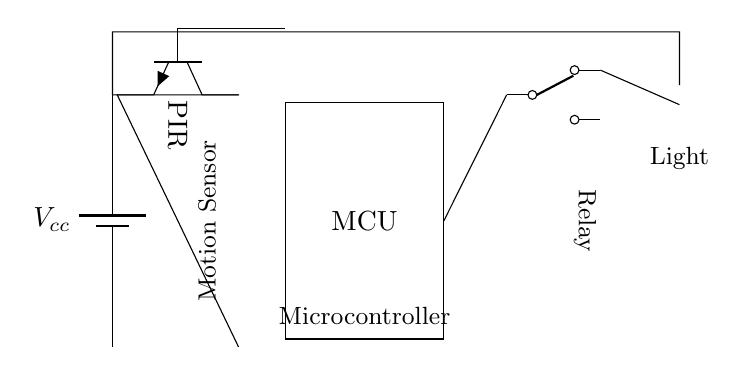What is the main component that detects occupancy? The main component that detects occupancy is the PIR sensor, which is indicated in the circuit diagram. It is used to sense motion.
Answer: PIR sensor What is the function of the microcontroller in this circuit? The microcontroller (MCU) processes the signal from the PIR sensor and controls the relay based on occupancy detection. It acts as the brain of the circuit.
Answer: Control What supplies power to this circuit? The circuit is powered by a battery labeled as Vcc, which provides the necessary voltage for the operation of all components.
Answer: Battery How many outputs does the relay have? The relay shown in the circuit diagram is a single-pole double-throw (SPDT) type, which means it has two outputs for switching.
Answer: Two What type of load is connected to the relay? The load connected to the relay in this circuit is a lamp, indicated by the lamp symbol in the diagram. It is the output device being controlled.
Answer: Lamp What happens when motion is detected? When motion is detected by the PIR sensor, it signals the microcontroller, which then activates the relay to turn on the lamp, illuminating the area.
Answer: Lamp turns on How does the PIR sensor communicate with the microcontroller? The PIR sensor outputs a signal that connects directly to the microcontroller, allowing it to send motion detection data for processing and response.
Answer: Direct connection 